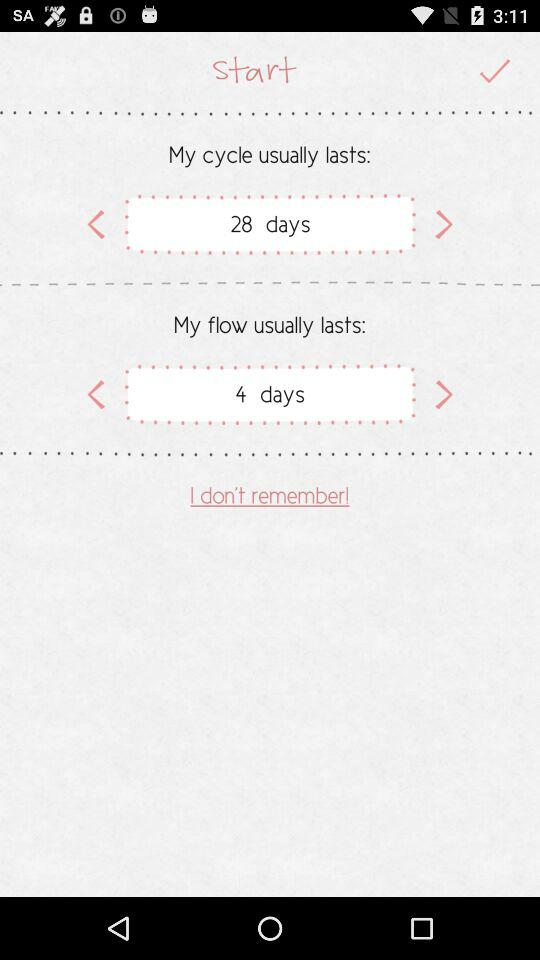When does the user's cycle start and end?
When the provided information is insufficient, respond with <no answer>. <no answer> 